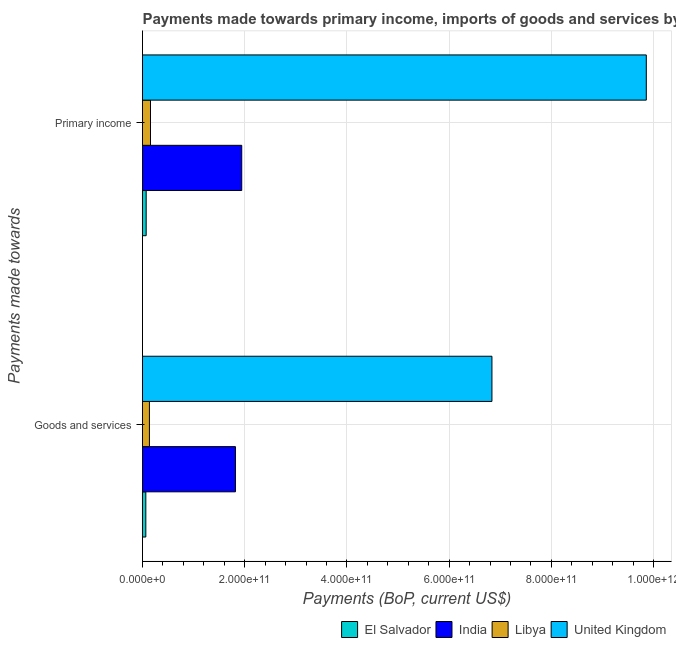Are the number of bars per tick equal to the number of legend labels?
Keep it short and to the point. Yes. What is the label of the 2nd group of bars from the top?
Your response must be concise. Goods and services. What is the payments made towards primary income in Libya?
Your answer should be very brief. 1.56e+1. Across all countries, what is the maximum payments made towards primary income?
Provide a short and direct response. 9.86e+11. Across all countries, what is the minimum payments made towards goods and services?
Keep it short and to the point. 6.51e+09. In which country was the payments made towards primary income minimum?
Keep it short and to the point. El Salvador. What is the total payments made towards primary income in the graph?
Keep it short and to the point. 1.20e+12. What is the difference between the payments made towards primary income in United Kingdom and that in El Salvador?
Make the answer very short. 9.79e+11. What is the difference between the payments made towards primary income in El Salvador and the payments made towards goods and services in United Kingdom?
Ensure brevity in your answer.  -6.77e+11. What is the average payments made towards primary income per country?
Your response must be concise. 3.01e+11. What is the difference between the payments made towards primary income and payments made towards goods and services in El Salvador?
Offer a very short reply. 6.65e+08. What is the ratio of the payments made towards primary income in Libya to that in India?
Provide a succinct answer. 0.08. Is the payments made towards primary income in Libya less than that in El Salvador?
Provide a succinct answer. No. In how many countries, is the payments made towards goods and services greater than the average payments made towards goods and services taken over all countries?
Your answer should be compact. 1. What does the 4th bar from the top in Goods and services represents?
Your answer should be compact. El Salvador. What does the 1st bar from the bottom in Primary income represents?
Ensure brevity in your answer.  El Salvador. What is the difference between two consecutive major ticks on the X-axis?
Provide a succinct answer. 2.00e+11. Are the values on the major ticks of X-axis written in scientific E-notation?
Give a very brief answer. Yes. Where does the legend appear in the graph?
Your response must be concise. Bottom right. How many legend labels are there?
Ensure brevity in your answer.  4. How are the legend labels stacked?
Provide a short and direct response. Horizontal. What is the title of the graph?
Keep it short and to the point. Payments made towards primary income, imports of goods and services by countries. Does "Kyrgyz Republic" appear as one of the legend labels in the graph?
Offer a terse response. No. What is the label or title of the X-axis?
Ensure brevity in your answer.  Payments (BoP, current US$). What is the label or title of the Y-axis?
Offer a very short reply. Payments made towards. What is the Payments (BoP, current US$) in El Salvador in Goods and services?
Provide a succinct answer. 6.51e+09. What is the Payments (BoP, current US$) in India in Goods and services?
Provide a short and direct response. 1.82e+11. What is the Payments (BoP, current US$) of Libya in Goods and services?
Your answer should be compact. 1.35e+1. What is the Payments (BoP, current US$) of United Kingdom in Goods and services?
Offer a terse response. 6.84e+11. What is the Payments (BoP, current US$) in El Salvador in Primary income?
Your response must be concise. 7.17e+09. What is the Payments (BoP, current US$) in India in Primary income?
Make the answer very short. 1.94e+11. What is the Payments (BoP, current US$) in Libya in Primary income?
Keep it short and to the point. 1.56e+1. What is the Payments (BoP, current US$) of United Kingdom in Primary income?
Your answer should be compact. 9.86e+11. Across all Payments made towards, what is the maximum Payments (BoP, current US$) of El Salvador?
Offer a very short reply. 7.17e+09. Across all Payments made towards, what is the maximum Payments (BoP, current US$) in India?
Keep it short and to the point. 1.94e+11. Across all Payments made towards, what is the maximum Payments (BoP, current US$) in Libya?
Make the answer very short. 1.56e+1. Across all Payments made towards, what is the maximum Payments (BoP, current US$) in United Kingdom?
Make the answer very short. 9.86e+11. Across all Payments made towards, what is the minimum Payments (BoP, current US$) of El Salvador?
Ensure brevity in your answer.  6.51e+09. Across all Payments made towards, what is the minimum Payments (BoP, current US$) of India?
Make the answer very short. 1.82e+11. Across all Payments made towards, what is the minimum Payments (BoP, current US$) of Libya?
Provide a succinct answer. 1.35e+1. Across all Payments made towards, what is the minimum Payments (BoP, current US$) of United Kingdom?
Offer a very short reply. 6.84e+11. What is the total Payments (BoP, current US$) of El Salvador in the graph?
Ensure brevity in your answer.  1.37e+1. What is the total Payments (BoP, current US$) in India in the graph?
Offer a terse response. 3.76e+11. What is the total Payments (BoP, current US$) of Libya in the graph?
Offer a terse response. 2.92e+1. What is the total Payments (BoP, current US$) in United Kingdom in the graph?
Offer a very short reply. 1.67e+12. What is the difference between the Payments (BoP, current US$) in El Salvador in Goods and services and that in Primary income?
Ensure brevity in your answer.  -6.65e+08. What is the difference between the Payments (BoP, current US$) in India in Goods and services and that in Primary income?
Your response must be concise. -1.23e+1. What is the difference between the Payments (BoP, current US$) in Libya in Goods and services and that in Primary income?
Your answer should be compact. -2.12e+09. What is the difference between the Payments (BoP, current US$) in United Kingdom in Goods and services and that in Primary income?
Provide a succinct answer. -3.02e+11. What is the difference between the Payments (BoP, current US$) of El Salvador in Goods and services and the Payments (BoP, current US$) of India in Primary income?
Offer a terse response. -1.88e+11. What is the difference between the Payments (BoP, current US$) of El Salvador in Goods and services and the Payments (BoP, current US$) of Libya in Primary income?
Give a very brief answer. -9.13e+09. What is the difference between the Payments (BoP, current US$) in El Salvador in Goods and services and the Payments (BoP, current US$) in United Kingdom in Primary income?
Keep it short and to the point. -9.79e+11. What is the difference between the Payments (BoP, current US$) of India in Goods and services and the Payments (BoP, current US$) of Libya in Primary income?
Give a very brief answer. 1.66e+11. What is the difference between the Payments (BoP, current US$) in India in Goods and services and the Payments (BoP, current US$) in United Kingdom in Primary income?
Your answer should be compact. -8.04e+11. What is the difference between the Payments (BoP, current US$) of Libya in Goods and services and the Payments (BoP, current US$) of United Kingdom in Primary income?
Provide a succinct answer. -9.72e+11. What is the average Payments (BoP, current US$) in El Salvador per Payments made towards?
Ensure brevity in your answer.  6.84e+09. What is the average Payments (BoP, current US$) in India per Payments made towards?
Your answer should be compact. 1.88e+11. What is the average Payments (BoP, current US$) in Libya per Payments made towards?
Provide a short and direct response. 1.46e+1. What is the average Payments (BoP, current US$) in United Kingdom per Payments made towards?
Ensure brevity in your answer.  8.35e+11. What is the difference between the Payments (BoP, current US$) of El Salvador and Payments (BoP, current US$) of India in Goods and services?
Your answer should be very brief. -1.75e+11. What is the difference between the Payments (BoP, current US$) in El Salvador and Payments (BoP, current US$) in Libya in Goods and services?
Your answer should be compact. -7.01e+09. What is the difference between the Payments (BoP, current US$) in El Salvador and Payments (BoP, current US$) in United Kingdom in Goods and services?
Offer a terse response. -6.77e+11. What is the difference between the Payments (BoP, current US$) in India and Payments (BoP, current US$) in Libya in Goods and services?
Your answer should be compact. 1.68e+11. What is the difference between the Payments (BoP, current US$) in India and Payments (BoP, current US$) in United Kingdom in Goods and services?
Give a very brief answer. -5.02e+11. What is the difference between the Payments (BoP, current US$) of Libya and Payments (BoP, current US$) of United Kingdom in Goods and services?
Your answer should be very brief. -6.70e+11. What is the difference between the Payments (BoP, current US$) in El Salvador and Payments (BoP, current US$) in India in Primary income?
Provide a short and direct response. -1.87e+11. What is the difference between the Payments (BoP, current US$) in El Salvador and Payments (BoP, current US$) in Libya in Primary income?
Provide a short and direct response. -8.47e+09. What is the difference between the Payments (BoP, current US$) in El Salvador and Payments (BoP, current US$) in United Kingdom in Primary income?
Keep it short and to the point. -9.79e+11. What is the difference between the Payments (BoP, current US$) in India and Payments (BoP, current US$) in Libya in Primary income?
Offer a very short reply. 1.79e+11. What is the difference between the Payments (BoP, current US$) of India and Payments (BoP, current US$) of United Kingdom in Primary income?
Make the answer very short. -7.92e+11. What is the difference between the Payments (BoP, current US$) in Libya and Payments (BoP, current US$) in United Kingdom in Primary income?
Your answer should be very brief. -9.70e+11. What is the ratio of the Payments (BoP, current US$) in El Salvador in Goods and services to that in Primary income?
Provide a succinct answer. 0.91. What is the ratio of the Payments (BoP, current US$) of India in Goods and services to that in Primary income?
Provide a succinct answer. 0.94. What is the ratio of the Payments (BoP, current US$) of Libya in Goods and services to that in Primary income?
Offer a terse response. 0.86. What is the ratio of the Payments (BoP, current US$) in United Kingdom in Goods and services to that in Primary income?
Offer a terse response. 0.69. What is the difference between the highest and the second highest Payments (BoP, current US$) in El Salvador?
Offer a terse response. 6.65e+08. What is the difference between the highest and the second highest Payments (BoP, current US$) in India?
Give a very brief answer. 1.23e+1. What is the difference between the highest and the second highest Payments (BoP, current US$) of Libya?
Keep it short and to the point. 2.12e+09. What is the difference between the highest and the second highest Payments (BoP, current US$) in United Kingdom?
Give a very brief answer. 3.02e+11. What is the difference between the highest and the lowest Payments (BoP, current US$) of El Salvador?
Your answer should be compact. 6.65e+08. What is the difference between the highest and the lowest Payments (BoP, current US$) of India?
Keep it short and to the point. 1.23e+1. What is the difference between the highest and the lowest Payments (BoP, current US$) of Libya?
Your answer should be compact. 2.12e+09. What is the difference between the highest and the lowest Payments (BoP, current US$) of United Kingdom?
Keep it short and to the point. 3.02e+11. 